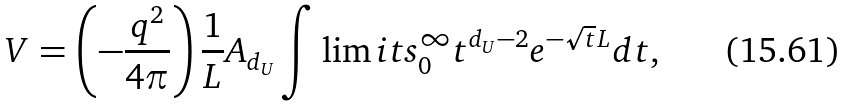Convert formula to latex. <formula><loc_0><loc_0><loc_500><loc_500>V = \left ( { - \frac { q ^ { 2 } } { 4 \pi } } \right ) \frac { 1 } { L } A _ { d _ { U } } \int \lim i t s _ { 0 } ^ { \infty } { t ^ { d _ { U } - 2 } } e ^ { - \sqrt { t } L } d t ,</formula> 